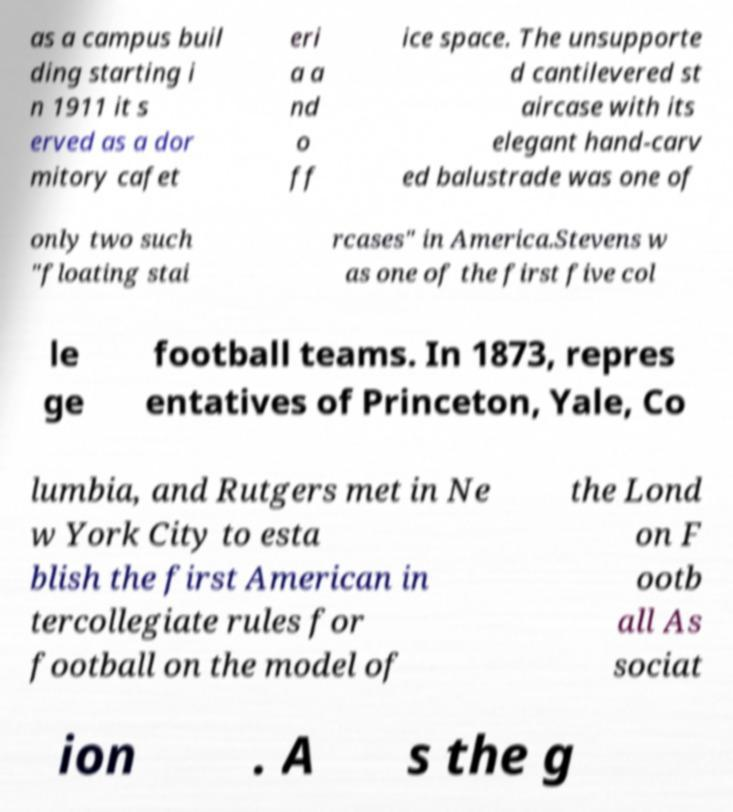Could you assist in decoding the text presented in this image and type it out clearly? as a campus buil ding starting i n 1911 it s erved as a dor mitory cafet eri a a nd o ff ice space. The unsupporte d cantilevered st aircase with its elegant hand-carv ed balustrade was one of only two such "floating stai rcases" in America.Stevens w as one of the first five col le ge football teams. In 1873, repres entatives of Princeton, Yale, Co lumbia, and Rutgers met in Ne w York City to esta blish the first American in tercollegiate rules for football on the model of the Lond on F ootb all As sociat ion . A s the g 